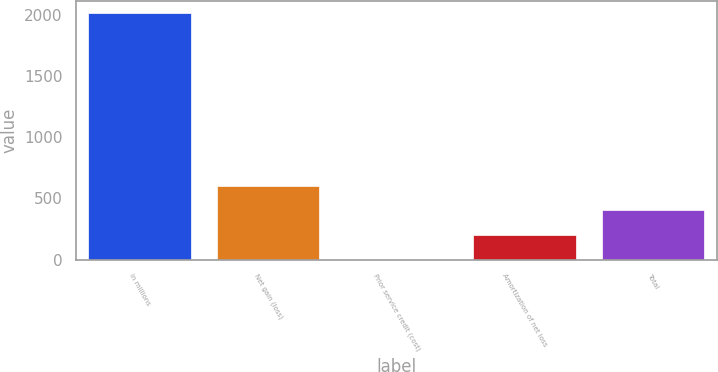<chart> <loc_0><loc_0><loc_500><loc_500><bar_chart><fcel>in millions<fcel>Net gain (loss)<fcel>Prior service credit (cost)<fcel>Amortization of net loss<fcel>Total<nl><fcel>2016<fcel>605.5<fcel>1<fcel>202.5<fcel>404<nl></chart> 